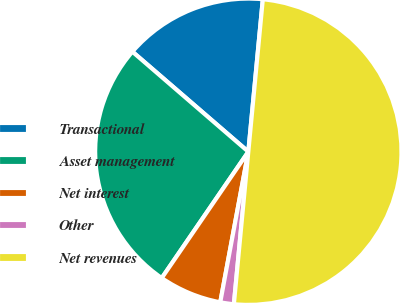<chart> <loc_0><loc_0><loc_500><loc_500><pie_chart><fcel>Transactional<fcel>Asset management<fcel>Net interest<fcel>Other<fcel>Net revenues<nl><fcel>15.18%<fcel>26.77%<fcel>6.63%<fcel>1.43%<fcel>50.0%<nl></chart> 